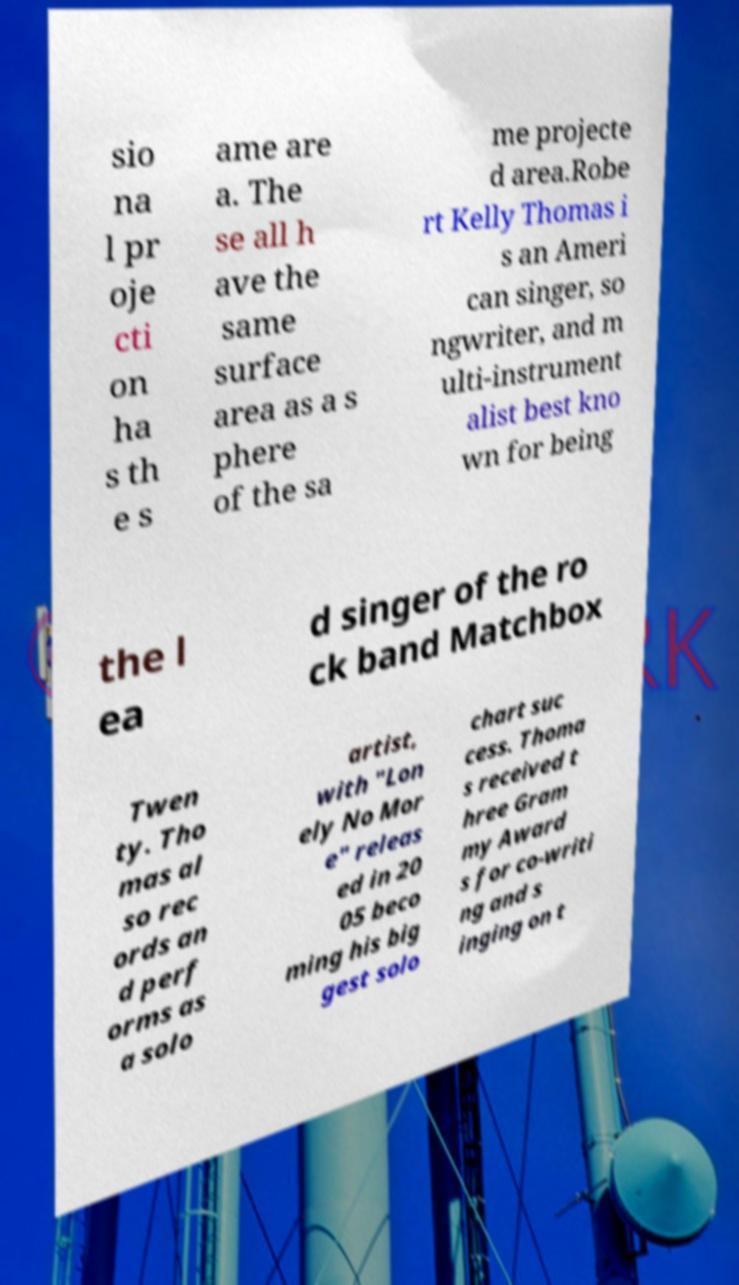What messages or text are displayed in this image? I need them in a readable, typed format. sio na l pr oje cti on ha s th e s ame are a. The se all h ave the same surface area as a s phere of the sa me projecte d area.Robe rt Kelly Thomas i s an Ameri can singer, so ngwriter, and m ulti-instrument alist best kno wn for being the l ea d singer of the ro ck band Matchbox Twen ty. Tho mas al so rec ords an d perf orms as a solo artist, with "Lon ely No Mor e" releas ed in 20 05 beco ming his big gest solo chart suc cess. Thoma s received t hree Gram my Award s for co-writi ng and s inging on t 